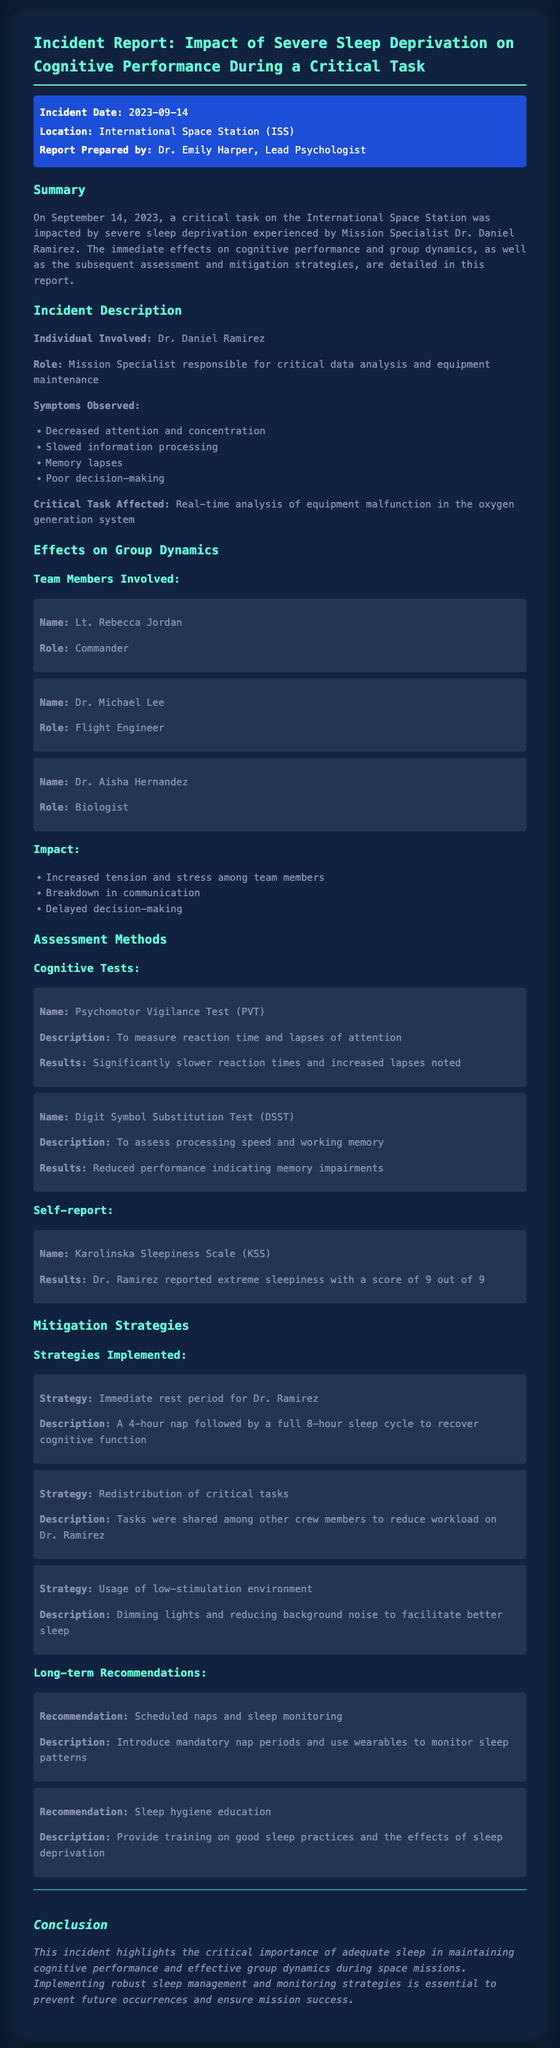What was the incident date? The incident date is mentioned in the meta-info section of the document.
Answer: 2023-09-14 Who prepared the report? The report states that Dr. Emily Harper is the lead psychologist and prepared the report.
Answer: Dr. Emily Harper What were the symptoms observed in Dr. Ramirez? The symptoms are listed in the incident description and detail cognitive impairments experienced by Dr. Ramirez.
Answer: Decreased attention and concentration What critical task was affected by sleep deprivation? The document outlines a specific task related to which Dr. Ramirez was responsible, indicating the critical nature of the task.
Answer: Real-time analysis of equipment malfunction What was the score on the Karolinska Sleepiness Scale for Dr. Ramirez? The results of the self-report assessment indicate Dr. Ramirez's level of sleepiness on a specific scale.
Answer: 9 out of 9 What mitigation strategy involved giving Dr. Ramirez a break? Several strategies are described in the mitigation section, and one specifically mentions a rest period.
Answer: Immediate rest period for Dr. Ramirez What long-term recommendation is suggested for sleep management? The document notes a specific recommendation targeting enhanced management of sleep patterns.
Answer: Scheduled naps and sleep monitoring What impact did sleep deprivation have on group dynamics? The document lists observable impacts on group dynamics that occurred due to the incident.
Answer: Increased tension and stress among team members 